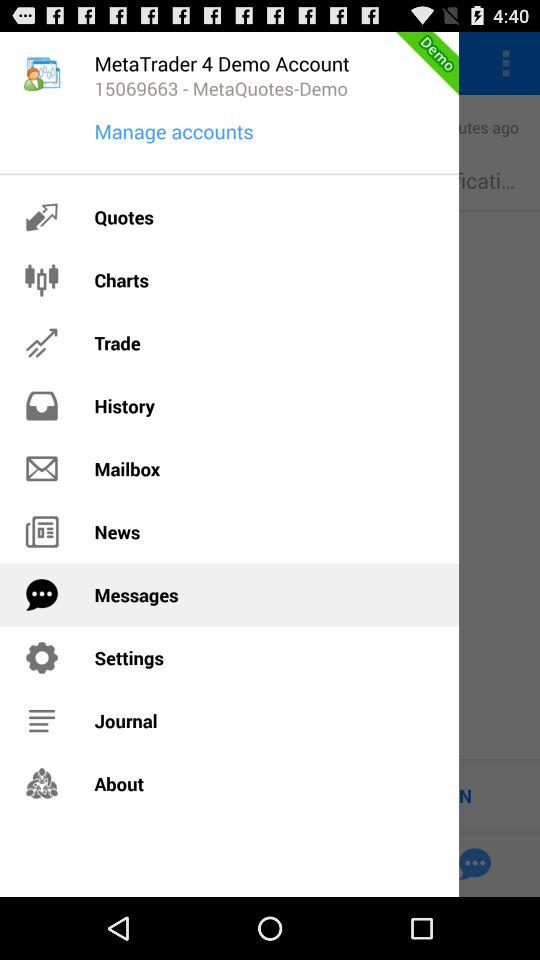Which item has been selected? The item "Messages" has been selected. 